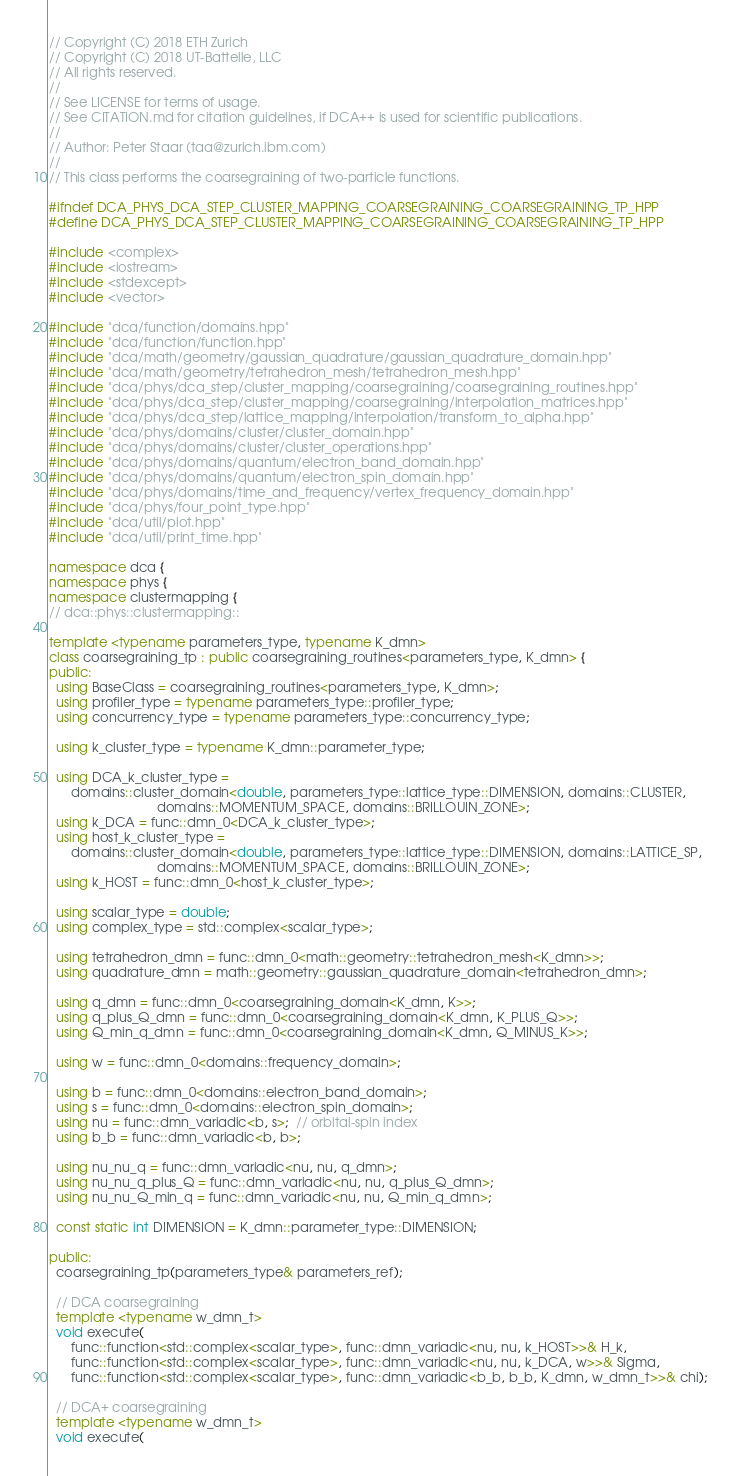Convert code to text. <code><loc_0><loc_0><loc_500><loc_500><_C++_>// Copyright (C) 2018 ETH Zurich
// Copyright (C) 2018 UT-Battelle, LLC
// All rights reserved.
//
// See LICENSE for terms of usage.
// See CITATION.md for citation guidelines, if DCA++ is used for scientific publications.
//
// Author: Peter Staar (taa@zurich.ibm.com)
//
// This class performs the coarsegraining of two-particle functions.

#ifndef DCA_PHYS_DCA_STEP_CLUSTER_MAPPING_COARSEGRAINING_COARSEGRAINING_TP_HPP
#define DCA_PHYS_DCA_STEP_CLUSTER_MAPPING_COARSEGRAINING_COARSEGRAINING_TP_HPP

#include <complex>
#include <iostream>
#include <stdexcept>
#include <vector>

#include "dca/function/domains.hpp"
#include "dca/function/function.hpp"
#include "dca/math/geometry/gaussian_quadrature/gaussian_quadrature_domain.hpp"
#include "dca/math/geometry/tetrahedron_mesh/tetrahedron_mesh.hpp"
#include "dca/phys/dca_step/cluster_mapping/coarsegraining/coarsegraining_routines.hpp"
#include "dca/phys/dca_step/cluster_mapping/coarsegraining/interpolation_matrices.hpp"
#include "dca/phys/dca_step/lattice_mapping/interpolation/transform_to_alpha.hpp"
#include "dca/phys/domains/cluster/cluster_domain.hpp"
#include "dca/phys/domains/cluster/cluster_operations.hpp"
#include "dca/phys/domains/quantum/electron_band_domain.hpp"
#include "dca/phys/domains/quantum/electron_spin_domain.hpp"
#include "dca/phys/domains/time_and_frequency/vertex_frequency_domain.hpp"
#include "dca/phys/four_point_type.hpp"
#include "dca/util/plot.hpp"
#include "dca/util/print_time.hpp"

namespace dca {
namespace phys {
namespace clustermapping {
// dca::phys::clustermapping::

template <typename parameters_type, typename K_dmn>
class coarsegraining_tp : public coarsegraining_routines<parameters_type, K_dmn> {
public:
  using BaseClass = coarsegraining_routines<parameters_type, K_dmn>;
  using profiler_type = typename parameters_type::profiler_type;
  using concurrency_type = typename parameters_type::concurrency_type;

  using k_cluster_type = typename K_dmn::parameter_type;

  using DCA_k_cluster_type =
      domains::cluster_domain<double, parameters_type::lattice_type::DIMENSION, domains::CLUSTER,
                              domains::MOMENTUM_SPACE, domains::BRILLOUIN_ZONE>;
  using k_DCA = func::dmn_0<DCA_k_cluster_type>;
  using host_k_cluster_type =
      domains::cluster_domain<double, parameters_type::lattice_type::DIMENSION, domains::LATTICE_SP,
                              domains::MOMENTUM_SPACE, domains::BRILLOUIN_ZONE>;
  using k_HOST = func::dmn_0<host_k_cluster_type>;

  using scalar_type = double;
  using complex_type = std::complex<scalar_type>;

  using tetrahedron_dmn = func::dmn_0<math::geometry::tetrahedron_mesh<K_dmn>>;
  using quadrature_dmn = math::geometry::gaussian_quadrature_domain<tetrahedron_dmn>;

  using q_dmn = func::dmn_0<coarsegraining_domain<K_dmn, K>>;
  using q_plus_Q_dmn = func::dmn_0<coarsegraining_domain<K_dmn, K_PLUS_Q>>;
  using Q_min_q_dmn = func::dmn_0<coarsegraining_domain<K_dmn, Q_MINUS_K>>;

  using w = func::dmn_0<domains::frequency_domain>;

  using b = func::dmn_0<domains::electron_band_domain>;
  using s = func::dmn_0<domains::electron_spin_domain>;
  using nu = func::dmn_variadic<b, s>;  // orbital-spin index
  using b_b = func::dmn_variadic<b, b>;

  using nu_nu_q = func::dmn_variadic<nu, nu, q_dmn>;
  using nu_nu_q_plus_Q = func::dmn_variadic<nu, nu, q_plus_Q_dmn>;
  using nu_nu_Q_min_q = func::dmn_variadic<nu, nu, Q_min_q_dmn>;

  const static int DIMENSION = K_dmn::parameter_type::DIMENSION;

public:
  coarsegraining_tp(parameters_type& parameters_ref);

  // DCA coarsegraining
  template <typename w_dmn_t>
  void execute(
      func::function<std::complex<scalar_type>, func::dmn_variadic<nu, nu, k_HOST>>& H_k,
      func::function<std::complex<scalar_type>, func::dmn_variadic<nu, nu, k_DCA, w>>& Sigma,
      func::function<std::complex<scalar_type>, func::dmn_variadic<b_b, b_b, K_dmn, w_dmn_t>>& chi);

  // DCA+ coarsegraining
  template <typename w_dmn_t>
  void execute(</code> 